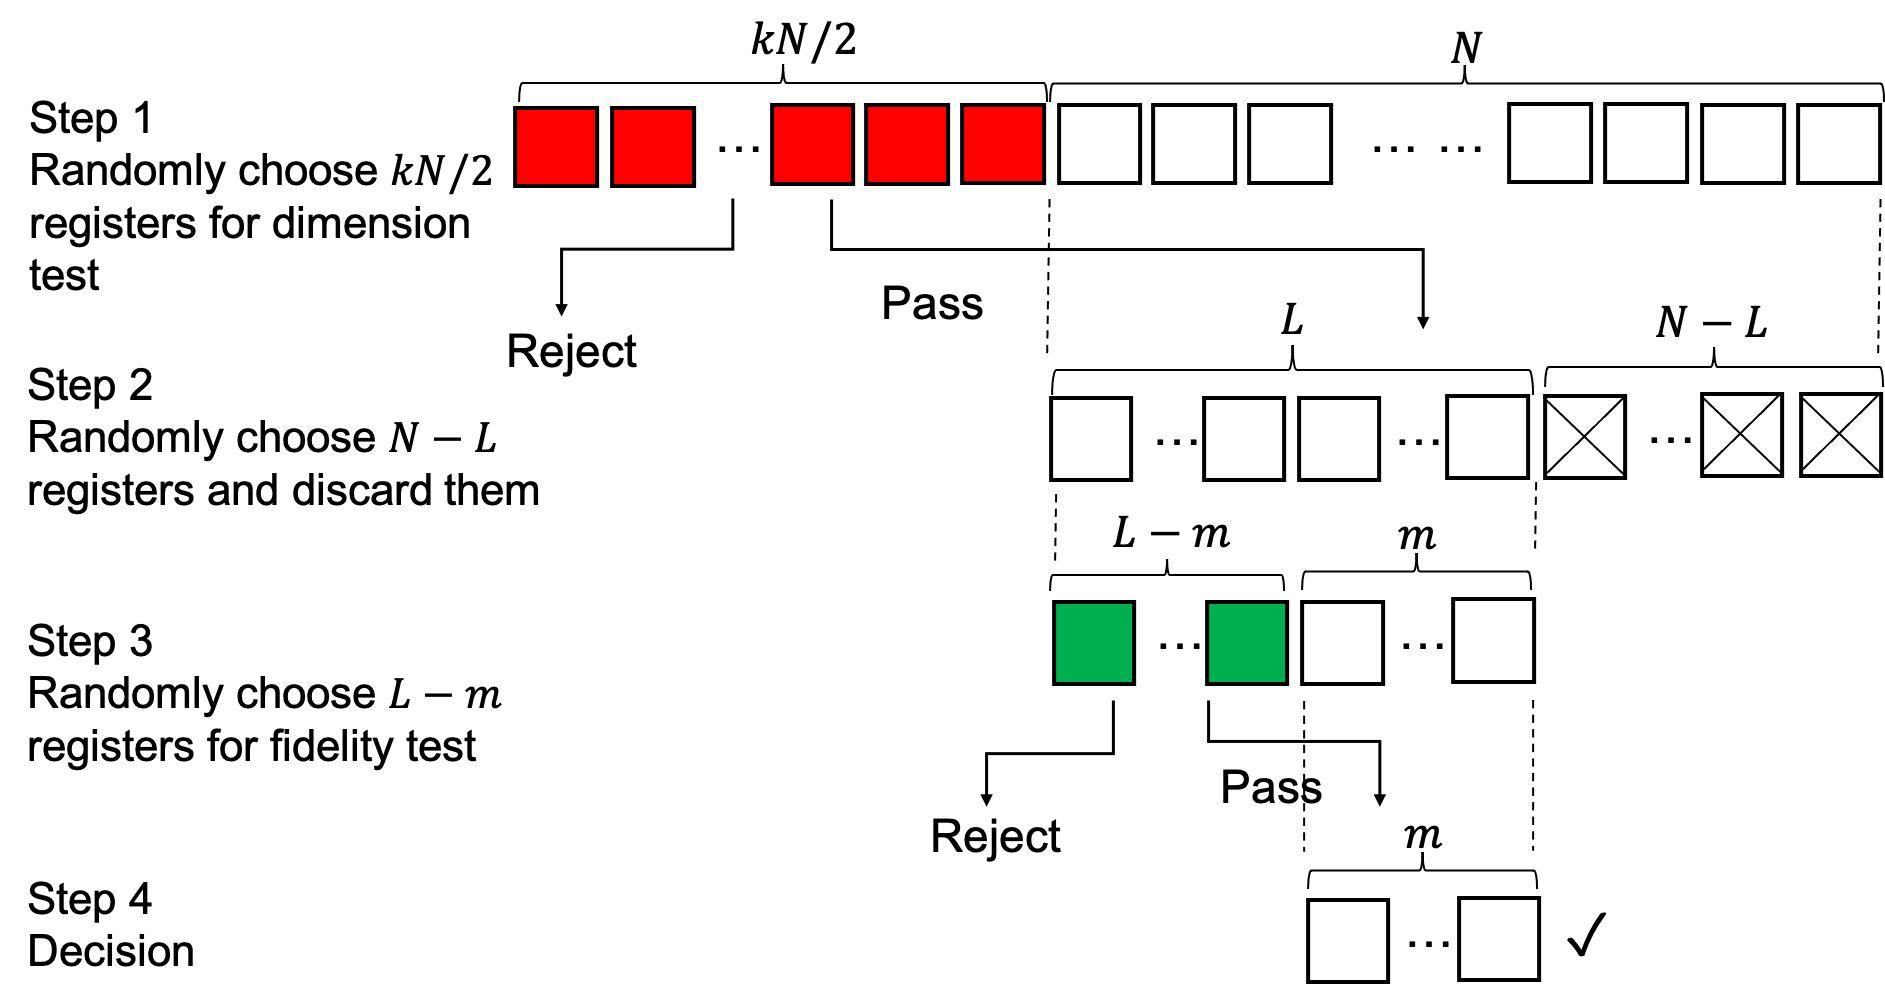According to the process depicted in the figure, what happens to the registers that do not pass the dimension test in Step 1? A. They are immediately discarded from the process. B. They are tested again in Step 3. C. They are set aside for the final decision. D. They are passed to Step 2 for further testing. The figure shows two pathways after Step 1: a "Reject" pathway for the registers that do not pass the dimension test, which implies that they are removed from the process, and a "Pass" pathway for the registers that continue to Step 2. Therefore, the registers that do not pass are discarded. Therefore, the correct answer is A. 